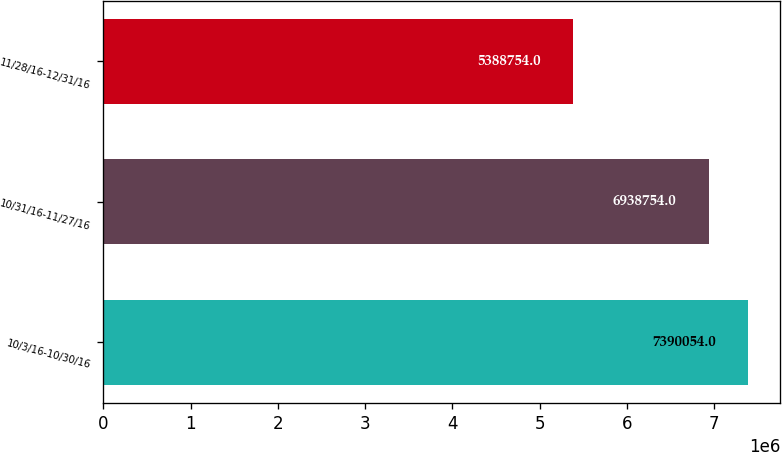Convert chart. <chart><loc_0><loc_0><loc_500><loc_500><bar_chart><fcel>10/3/16-10/30/16<fcel>10/31/16-11/27/16<fcel>11/28/16-12/31/16<nl><fcel>7.39005e+06<fcel>6.93875e+06<fcel>5.38875e+06<nl></chart> 